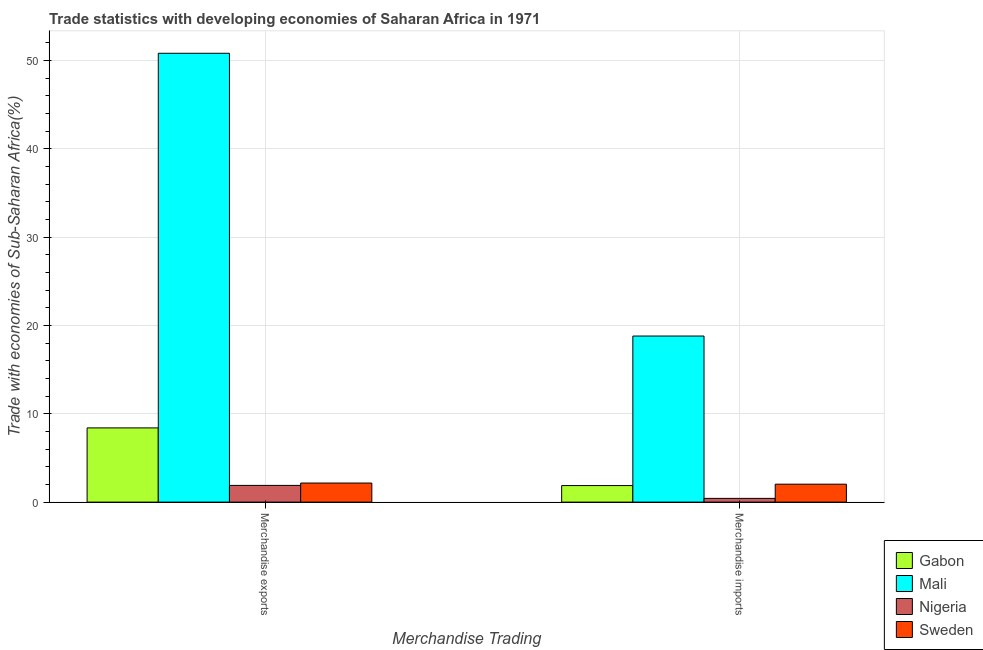How many different coloured bars are there?
Ensure brevity in your answer.  4. How many groups of bars are there?
Offer a terse response. 2. Are the number of bars per tick equal to the number of legend labels?
Ensure brevity in your answer.  Yes. Are the number of bars on each tick of the X-axis equal?
Your answer should be compact. Yes. What is the label of the 1st group of bars from the left?
Provide a succinct answer. Merchandise exports. What is the merchandise exports in Gabon?
Provide a short and direct response. 8.41. Across all countries, what is the maximum merchandise imports?
Give a very brief answer. 18.81. Across all countries, what is the minimum merchandise exports?
Give a very brief answer. 1.89. In which country was the merchandise imports maximum?
Offer a terse response. Mali. In which country was the merchandise imports minimum?
Provide a succinct answer. Nigeria. What is the total merchandise exports in the graph?
Provide a succinct answer. 63.3. What is the difference between the merchandise imports in Gabon and that in Sweden?
Give a very brief answer. -0.16. What is the difference between the merchandise imports in Mali and the merchandise exports in Nigeria?
Your answer should be very brief. 16.92. What is the average merchandise exports per country?
Ensure brevity in your answer.  15.82. What is the difference between the merchandise imports and merchandise exports in Sweden?
Your response must be concise. -0.13. In how many countries, is the merchandise exports greater than 30 %?
Provide a succinct answer. 1. What is the ratio of the merchandise imports in Mali to that in Sweden?
Ensure brevity in your answer.  9.26. In how many countries, is the merchandise exports greater than the average merchandise exports taken over all countries?
Provide a short and direct response. 1. What does the 3rd bar from the left in Merchandise imports represents?
Keep it short and to the point. Nigeria. What does the 3rd bar from the right in Merchandise imports represents?
Ensure brevity in your answer.  Mali. How many bars are there?
Your answer should be compact. 8. What is the difference between two consecutive major ticks on the Y-axis?
Ensure brevity in your answer.  10. Are the values on the major ticks of Y-axis written in scientific E-notation?
Provide a succinct answer. No. Does the graph contain any zero values?
Your response must be concise. No. Does the graph contain grids?
Provide a short and direct response. Yes. Where does the legend appear in the graph?
Keep it short and to the point. Bottom right. How many legend labels are there?
Offer a very short reply. 4. How are the legend labels stacked?
Your answer should be compact. Vertical. What is the title of the graph?
Your response must be concise. Trade statistics with developing economies of Saharan Africa in 1971. Does "Singapore" appear as one of the legend labels in the graph?
Your response must be concise. No. What is the label or title of the X-axis?
Keep it short and to the point. Merchandise Trading. What is the label or title of the Y-axis?
Give a very brief answer. Trade with economies of Sub-Saharan Africa(%). What is the Trade with economies of Sub-Saharan Africa(%) of Gabon in Merchandise exports?
Your answer should be very brief. 8.41. What is the Trade with economies of Sub-Saharan Africa(%) of Mali in Merchandise exports?
Make the answer very short. 50.83. What is the Trade with economies of Sub-Saharan Africa(%) in Nigeria in Merchandise exports?
Your response must be concise. 1.89. What is the Trade with economies of Sub-Saharan Africa(%) in Sweden in Merchandise exports?
Ensure brevity in your answer.  2.16. What is the Trade with economies of Sub-Saharan Africa(%) of Gabon in Merchandise imports?
Ensure brevity in your answer.  1.88. What is the Trade with economies of Sub-Saharan Africa(%) of Mali in Merchandise imports?
Provide a succinct answer. 18.81. What is the Trade with economies of Sub-Saharan Africa(%) in Nigeria in Merchandise imports?
Offer a very short reply. 0.42. What is the Trade with economies of Sub-Saharan Africa(%) of Sweden in Merchandise imports?
Your response must be concise. 2.03. Across all Merchandise Trading, what is the maximum Trade with economies of Sub-Saharan Africa(%) of Gabon?
Ensure brevity in your answer.  8.41. Across all Merchandise Trading, what is the maximum Trade with economies of Sub-Saharan Africa(%) of Mali?
Offer a very short reply. 50.83. Across all Merchandise Trading, what is the maximum Trade with economies of Sub-Saharan Africa(%) of Nigeria?
Make the answer very short. 1.89. Across all Merchandise Trading, what is the maximum Trade with economies of Sub-Saharan Africa(%) of Sweden?
Ensure brevity in your answer.  2.16. Across all Merchandise Trading, what is the minimum Trade with economies of Sub-Saharan Africa(%) of Gabon?
Offer a terse response. 1.88. Across all Merchandise Trading, what is the minimum Trade with economies of Sub-Saharan Africa(%) in Mali?
Offer a terse response. 18.81. Across all Merchandise Trading, what is the minimum Trade with economies of Sub-Saharan Africa(%) of Nigeria?
Your answer should be compact. 0.42. Across all Merchandise Trading, what is the minimum Trade with economies of Sub-Saharan Africa(%) of Sweden?
Your answer should be very brief. 2.03. What is the total Trade with economies of Sub-Saharan Africa(%) of Gabon in the graph?
Your answer should be very brief. 10.28. What is the total Trade with economies of Sub-Saharan Africa(%) of Mali in the graph?
Offer a terse response. 69.65. What is the total Trade with economies of Sub-Saharan Africa(%) in Nigeria in the graph?
Your answer should be compact. 2.32. What is the total Trade with economies of Sub-Saharan Africa(%) in Sweden in the graph?
Provide a succinct answer. 4.19. What is the difference between the Trade with economies of Sub-Saharan Africa(%) in Gabon in Merchandise exports and that in Merchandise imports?
Give a very brief answer. 6.53. What is the difference between the Trade with economies of Sub-Saharan Africa(%) of Mali in Merchandise exports and that in Merchandise imports?
Your answer should be very brief. 32.02. What is the difference between the Trade with economies of Sub-Saharan Africa(%) in Nigeria in Merchandise exports and that in Merchandise imports?
Ensure brevity in your answer.  1.47. What is the difference between the Trade with economies of Sub-Saharan Africa(%) of Sweden in Merchandise exports and that in Merchandise imports?
Keep it short and to the point. 0.13. What is the difference between the Trade with economies of Sub-Saharan Africa(%) in Gabon in Merchandise exports and the Trade with economies of Sub-Saharan Africa(%) in Mali in Merchandise imports?
Ensure brevity in your answer.  -10.4. What is the difference between the Trade with economies of Sub-Saharan Africa(%) in Gabon in Merchandise exports and the Trade with economies of Sub-Saharan Africa(%) in Nigeria in Merchandise imports?
Give a very brief answer. 7.98. What is the difference between the Trade with economies of Sub-Saharan Africa(%) in Gabon in Merchandise exports and the Trade with economies of Sub-Saharan Africa(%) in Sweden in Merchandise imports?
Provide a short and direct response. 6.37. What is the difference between the Trade with economies of Sub-Saharan Africa(%) in Mali in Merchandise exports and the Trade with economies of Sub-Saharan Africa(%) in Nigeria in Merchandise imports?
Your response must be concise. 50.41. What is the difference between the Trade with economies of Sub-Saharan Africa(%) in Mali in Merchandise exports and the Trade with economies of Sub-Saharan Africa(%) in Sweden in Merchandise imports?
Your answer should be compact. 48.8. What is the difference between the Trade with economies of Sub-Saharan Africa(%) in Nigeria in Merchandise exports and the Trade with economies of Sub-Saharan Africa(%) in Sweden in Merchandise imports?
Ensure brevity in your answer.  -0.14. What is the average Trade with economies of Sub-Saharan Africa(%) of Gabon per Merchandise Trading?
Offer a very short reply. 5.14. What is the average Trade with economies of Sub-Saharan Africa(%) in Mali per Merchandise Trading?
Your response must be concise. 34.82. What is the average Trade with economies of Sub-Saharan Africa(%) in Nigeria per Merchandise Trading?
Your answer should be compact. 1.16. What is the average Trade with economies of Sub-Saharan Africa(%) of Sweden per Merchandise Trading?
Ensure brevity in your answer.  2.1. What is the difference between the Trade with economies of Sub-Saharan Africa(%) in Gabon and Trade with economies of Sub-Saharan Africa(%) in Mali in Merchandise exports?
Your answer should be very brief. -42.43. What is the difference between the Trade with economies of Sub-Saharan Africa(%) of Gabon and Trade with economies of Sub-Saharan Africa(%) of Nigeria in Merchandise exports?
Ensure brevity in your answer.  6.51. What is the difference between the Trade with economies of Sub-Saharan Africa(%) of Gabon and Trade with economies of Sub-Saharan Africa(%) of Sweden in Merchandise exports?
Provide a succinct answer. 6.24. What is the difference between the Trade with economies of Sub-Saharan Africa(%) in Mali and Trade with economies of Sub-Saharan Africa(%) in Nigeria in Merchandise exports?
Your response must be concise. 48.94. What is the difference between the Trade with economies of Sub-Saharan Africa(%) of Mali and Trade with economies of Sub-Saharan Africa(%) of Sweden in Merchandise exports?
Your answer should be very brief. 48.67. What is the difference between the Trade with economies of Sub-Saharan Africa(%) in Nigeria and Trade with economies of Sub-Saharan Africa(%) in Sweden in Merchandise exports?
Your answer should be compact. -0.27. What is the difference between the Trade with economies of Sub-Saharan Africa(%) of Gabon and Trade with economies of Sub-Saharan Africa(%) of Mali in Merchandise imports?
Provide a succinct answer. -16.94. What is the difference between the Trade with economies of Sub-Saharan Africa(%) in Gabon and Trade with economies of Sub-Saharan Africa(%) in Nigeria in Merchandise imports?
Ensure brevity in your answer.  1.45. What is the difference between the Trade with economies of Sub-Saharan Africa(%) of Gabon and Trade with economies of Sub-Saharan Africa(%) of Sweden in Merchandise imports?
Provide a short and direct response. -0.16. What is the difference between the Trade with economies of Sub-Saharan Africa(%) in Mali and Trade with economies of Sub-Saharan Africa(%) in Nigeria in Merchandise imports?
Offer a very short reply. 18.39. What is the difference between the Trade with economies of Sub-Saharan Africa(%) in Mali and Trade with economies of Sub-Saharan Africa(%) in Sweden in Merchandise imports?
Offer a very short reply. 16.78. What is the difference between the Trade with economies of Sub-Saharan Africa(%) in Nigeria and Trade with economies of Sub-Saharan Africa(%) in Sweden in Merchandise imports?
Keep it short and to the point. -1.61. What is the ratio of the Trade with economies of Sub-Saharan Africa(%) of Gabon in Merchandise exports to that in Merchandise imports?
Provide a short and direct response. 4.48. What is the ratio of the Trade with economies of Sub-Saharan Africa(%) of Mali in Merchandise exports to that in Merchandise imports?
Offer a very short reply. 2.7. What is the ratio of the Trade with economies of Sub-Saharan Africa(%) of Nigeria in Merchandise exports to that in Merchandise imports?
Provide a short and direct response. 4.47. What is the ratio of the Trade with economies of Sub-Saharan Africa(%) of Sweden in Merchandise exports to that in Merchandise imports?
Your response must be concise. 1.06. What is the difference between the highest and the second highest Trade with economies of Sub-Saharan Africa(%) of Gabon?
Offer a terse response. 6.53. What is the difference between the highest and the second highest Trade with economies of Sub-Saharan Africa(%) of Mali?
Your answer should be compact. 32.02. What is the difference between the highest and the second highest Trade with economies of Sub-Saharan Africa(%) of Nigeria?
Keep it short and to the point. 1.47. What is the difference between the highest and the second highest Trade with economies of Sub-Saharan Africa(%) in Sweden?
Offer a terse response. 0.13. What is the difference between the highest and the lowest Trade with economies of Sub-Saharan Africa(%) in Gabon?
Give a very brief answer. 6.53. What is the difference between the highest and the lowest Trade with economies of Sub-Saharan Africa(%) in Mali?
Offer a very short reply. 32.02. What is the difference between the highest and the lowest Trade with economies of Sub-Saharan Africa(%) of Nigeria?
Offer a terse response. 1.47. What is the difference between the highest and the lowest Trade with economies of Sub-Saharan Africa(%) of Sweden?
Offer a terse response. 0.13. 